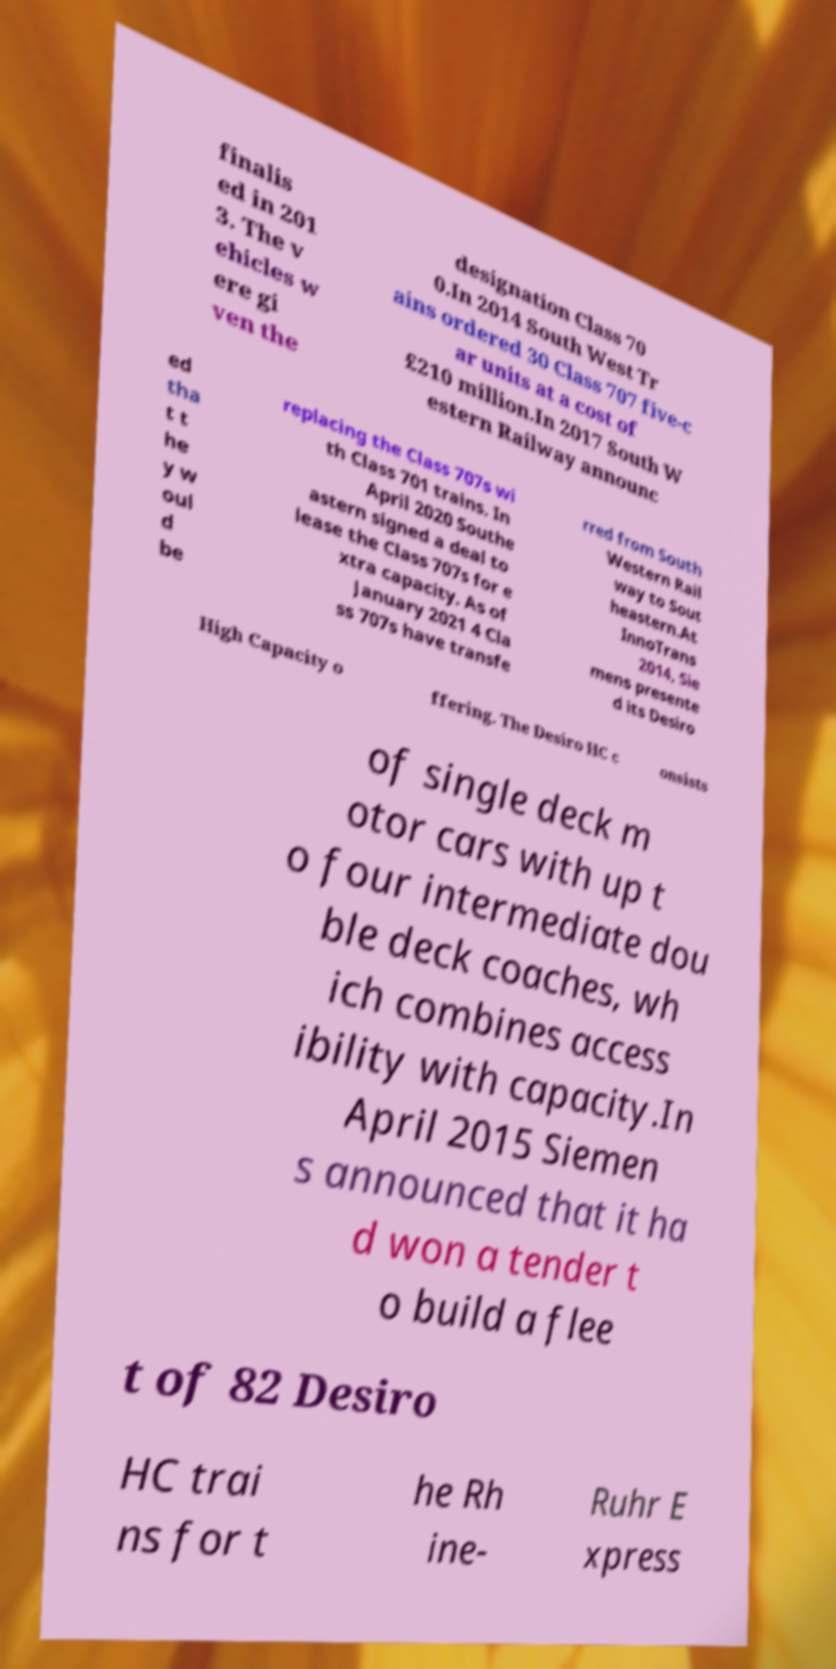What messages or text are displayed in this image? I need them in a readable, typed format. finalis ed in 201 3. The v ehicles w ere gi ven the designation Class 70 0.In 2014 South West Tr ains ordered 30 Class 707 five-c ar units at a cost of £210 million.In 2017 South W estern Railway announc ed tha t t he y w oul d be replacing the Class 707s wi th Class 701 trains. In April 2020 Southe astern signed a deal to lease the Class 707s for e xtra capacity. As of January 2021 4 Cla ss 707s have transfe rred from South Western Rail way to Sout heastern.At InnoTrans 2014, Sie mens presente d its Desiro High Capacity o ffering. The Desiro HC c onsists of single deck m otor cars with up t o four intermediate dou ble deck coaches, wh ich combines access ibility with capacity.In April 2015 Siemen s announced that it ha d won a tender t o build a flee t of 82 Desiro HC trai ns for t he Rh ine- Ruhr E xpress 